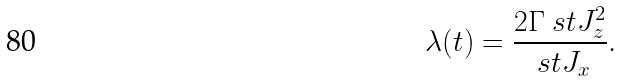Convert formula to latex. <formula><loc_0><loc_0><loc_500><loc_500>\lambda ( t ) = \frac { 2 \Gamma \ s t { J _ { z } ^ { 2 } } } { \ s t { J _ { x } } } .</formula> 